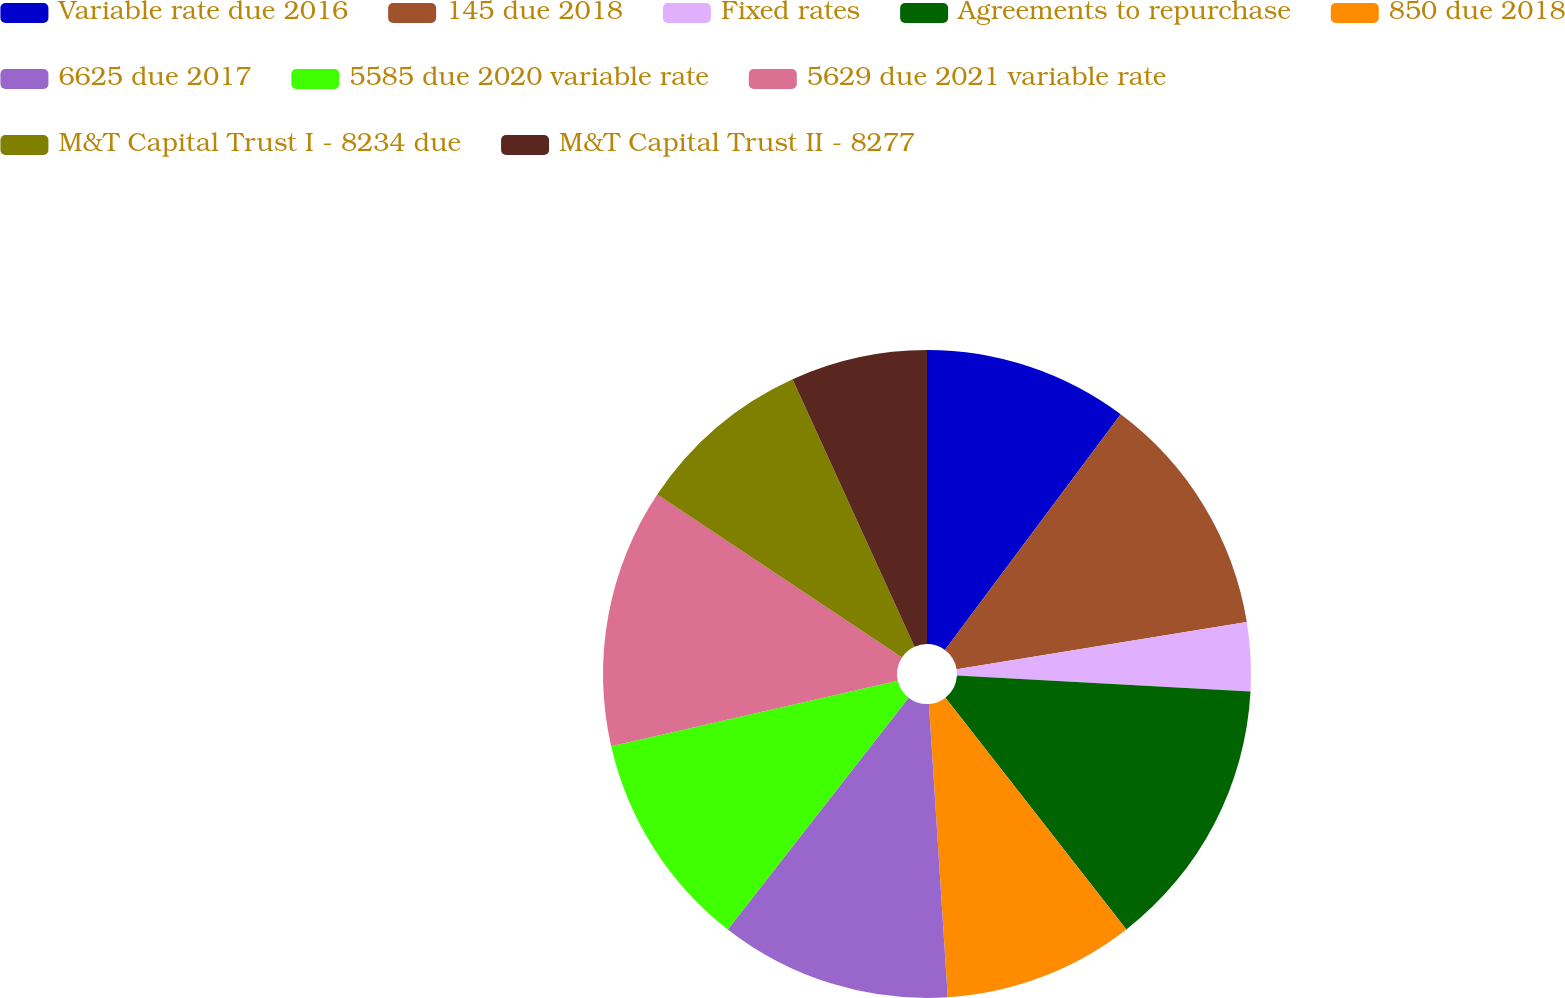Convert chart. <chart><loc_0><loc_0><loc_500><loc_500><pie_chart><fcel>Variable rate due 2016<fcel>145 due 2018<fcel>Fixed rates<fcel>Agreements to repurchase<fcel>850 due 2018<fcel>6625 due 2017<fcel>5585 due 2020 variable rate<fcel>5629 due 2021 variable rate<fcel>M&T Capital Trust I - 8234 due<fcel>M&T Capital Trust II - 8277<nl><fcel>10.2%<fcel>12.24%<fcel>3.42%<fcel>13.59%<fcel>9.53%<fcel>11.56%<fcel>10.88%<fcel>12.92%<fcel>8.85%<fcel>6.81%<nl></chart> 